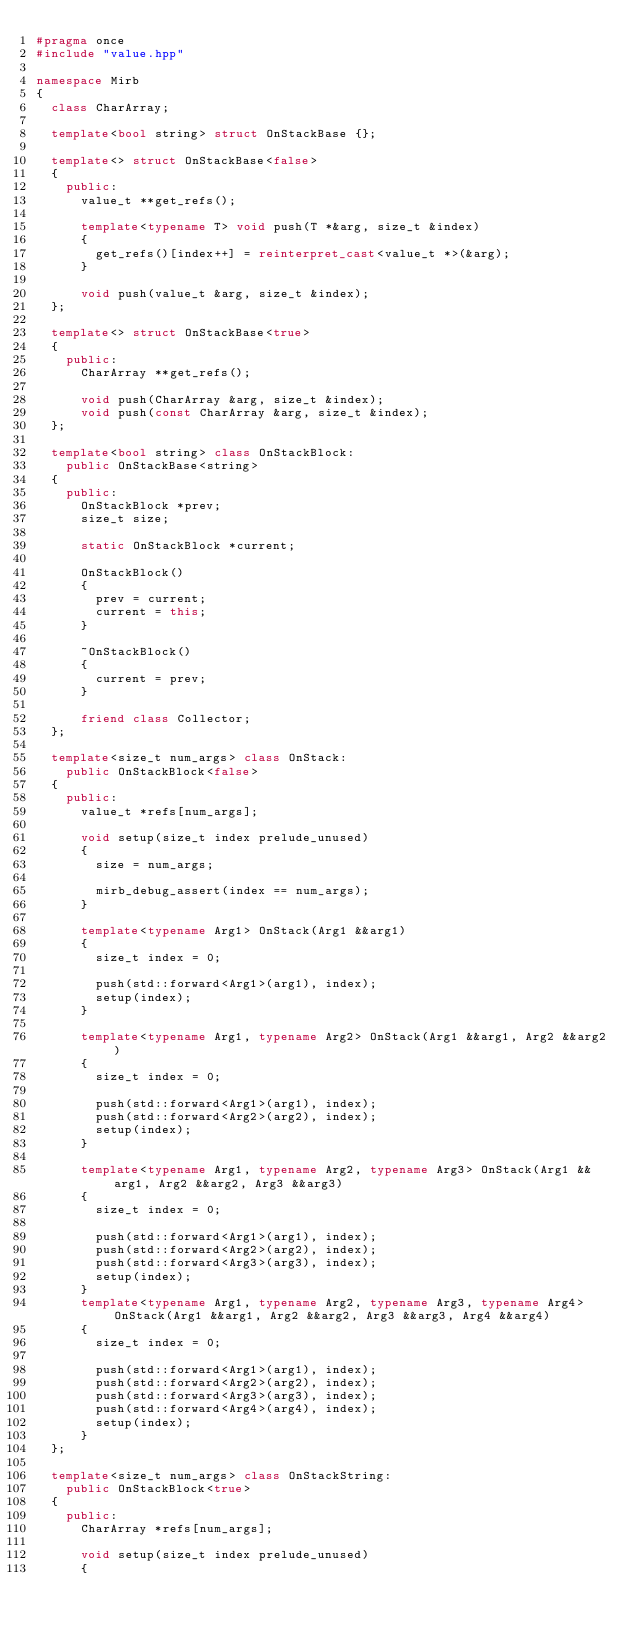<code> <loc_0><loc_0><loc_500><loc_500><_C++_>#pragma once
#include "value.hpp"

namespace Mirb
{
	class CharArray;
	
	template<bool string> struct OnStackBase {};
	
	template<> struct OnStackBase<false>
	{
		public:
			value_t **get_refs();

			template<typename T> void push(T *&arg, size_t &index)
			{
				get_refs()[index++] = reinterpret_cast<value_t *>(&arg);
			}

			void push(value_t &arg, size_t &index);
	};

	template<> struct OnStackBase<true>
	{
		public:
			CharArray **get_refs();
			
			void push(CharArray &arg, size_t &index);
			void push(const CharArray &arg, size_t &index);
	};

	template<bool string> class OnStackBlock:
		public OnStackBase<string>
	{
		public:
			OnStackBlock *prev;
			size_t size;

			static OnStackBlock *current;

			OnStackBlock()
			{
				prev = current;
				current = this;
			}

			~OnStackBlock()
			{
				current = prev;
			}
			
			friend class Collector;
	};
	
	template<size_t num_args> class OnStack:
		public OnStackBlock<false>
	{
		public:
			value_t *refs[num_args];
			
			void setup(size_t index prelude_unused)
			{
				size = num_args;

				mirb_debug_assert(index == num_args);
			}

			template<typename Arg1> OnStack(Arg1 &&arg1)
			{
				size_t index = 0;

				push(std::forward<Arg1>(arg1), index);
				setup(index);
			}

			template<typename Arg1, typename Arg2> OnStack(Arg1 &&arg1, Arg2 &&arg2)
			{
				size_t index = 0;
				
				push(std::forward<Arg1>(arg1), index);
				push(std::forward<Arg2>(arg2), index);
				setup(index);
			}
			
			template<typename Arg1, typename Arg2, typename Arg3> OnStack(Arg1 &&arg1, Arg2 &&arg2, Arg3 &&arg3)
			{
				size_t index = 0;
				
				push(std::forward<Arg1>(arg1), index);
				push(std::forward<Arg2>(arg2), index);
				push(std::forward<Arg3>(arg3), index);
				setup(index);
			}
			template<typename Arg1, typename Arg2, typename Arg3, typename Arg4> OnStack(Arg1 &&arg1, Arg2 &&arg2, Arg3 &&arg3, Arg4 &&arg4)
			{
				size_t index = 0;
				
				push(std::forward<Arg1>(arg1), index);
				push(std::forward<Arg2>(arg2), index);
				push(std::forward<Arg3>(arg3), index);
				push(std::forward<Arg4>(arg4), index);
				setup(index);
			}
	};

	template<size_t num_args> class OnStackString:
		public OnStackBlock<true>
	{
		public:
			CharArray *refs[num_args];
			
			void setup(size_t index prelude_unused)
			{</code> 